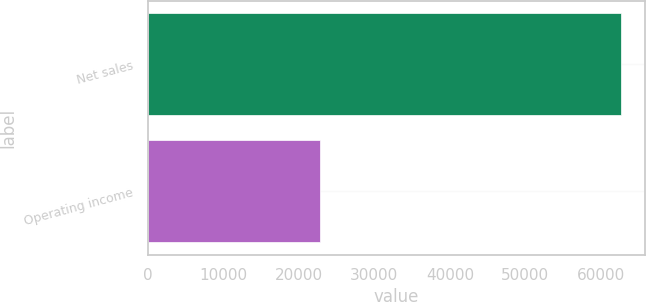<chart> <loc_0><loc_0><loc_500><loc_500><bar_chart><fcel>Net sales<fcel>Operating income<nl><fcel>62739<fcel>22817<nl></chart> 